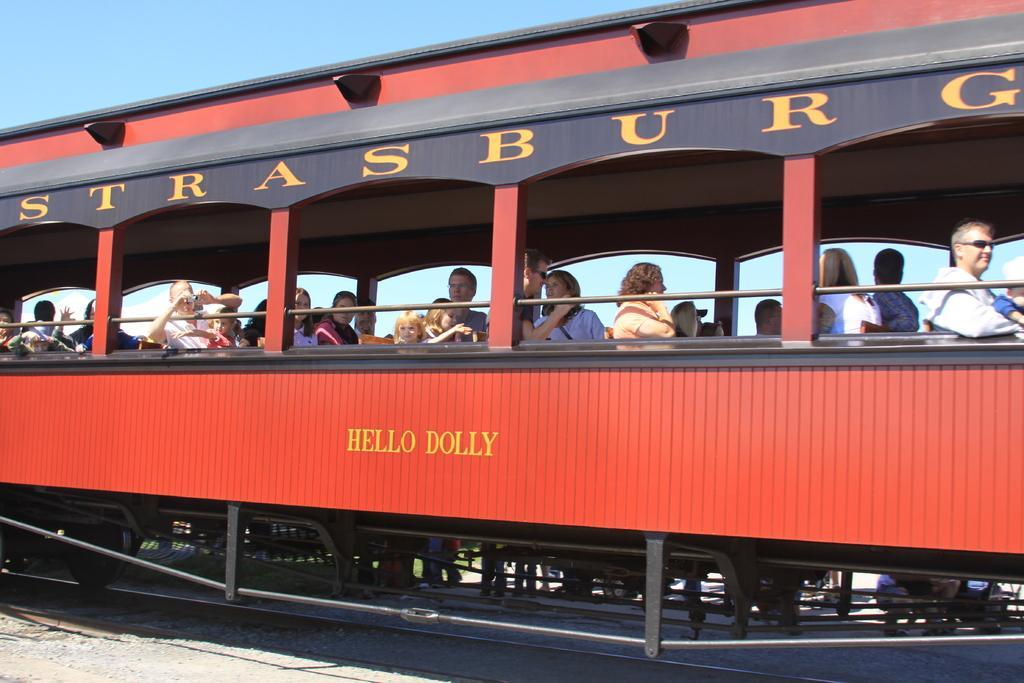How would you summarize this image in a sentence or two? In this image, I can see groups of people sitting in the train. This train is on the railway track. I can see a person holding a camera. These are the letters written on the train. I think this is the sky. 